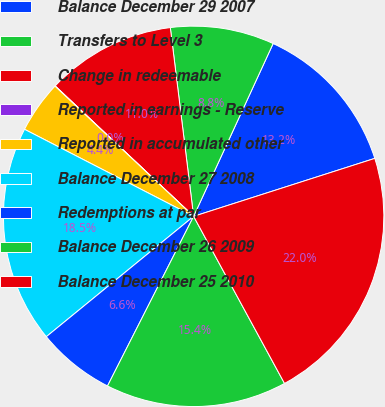<chart> <loc_0><loc_0><loc_500><loc_500><pie_chart><fcel>Balance December 29 2007<fcel>Transfers to Level 3<fcel>Change in redeemable<fcel>Reported in earnings - Reserve<fcel>Reported in accumulated other<fcel>Balance December 27 2008<fcel>Redemptions at par<fcel>Balance December 26 2009<fcel>Balance December 25 2010<nl><fcel>13.21%<fcel>8.82%<fcel>11.02%<fcel>0.03%<fcel>4.43%<fcel>18.47%<fcel>6.62%<fcel>15.41%<fcel>22.0%<nl></chart> 